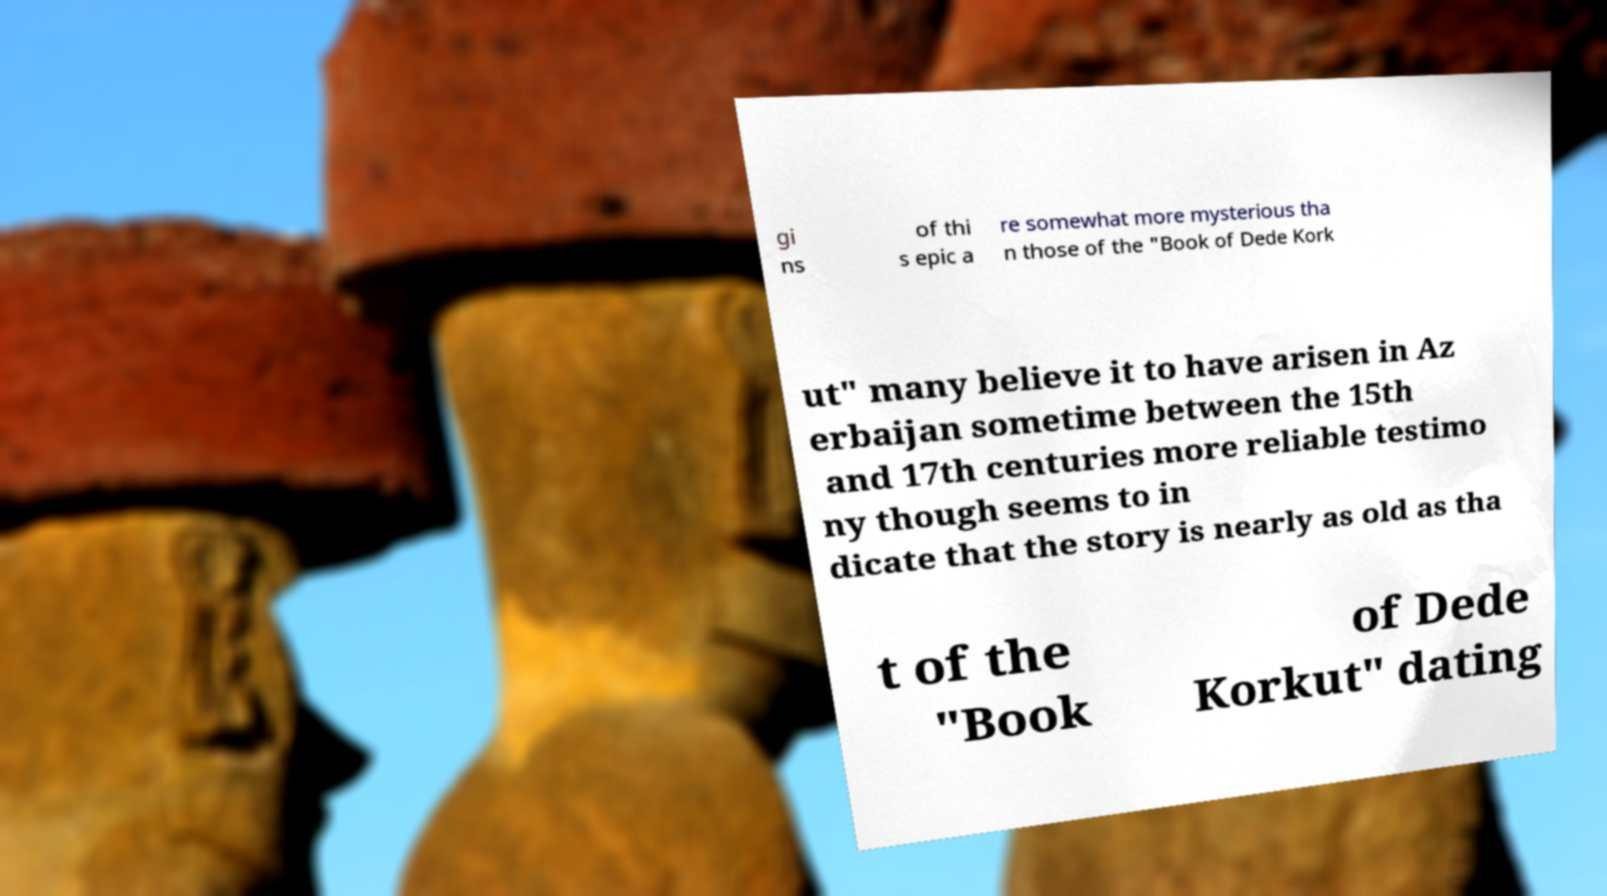Could you assist in decoding the text presented in this image and type it out clearly? gi ns of thi s epic a re somewhat more mysterious tha n those of the "Book of Dede Kork ut" many believe it to have arisen in Az erbaijan sometime between the 15th and 17th centuries more reliable testimo ny though seems to in dicate that the story is nearly as old as tha t of the "Book of Dede Korkut" dating 